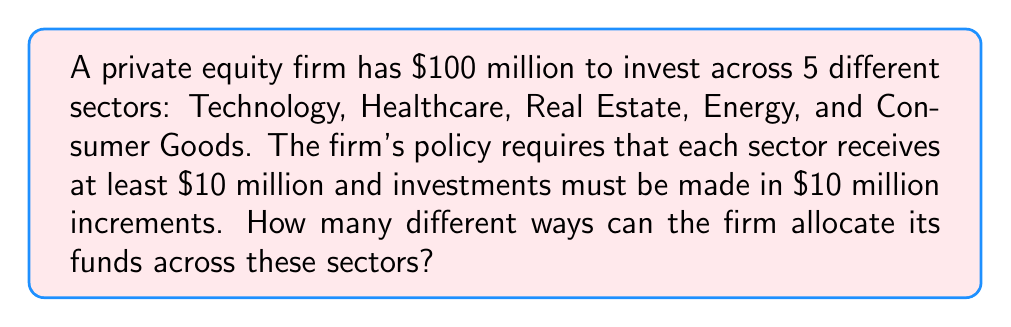Teach me how to tackle this problem. Let's approach this step-by-step:

1) First, we need to realize that this is a stars and bars problem with some constraints.

2) We have $100 million to distribute, but each sector must receive at least $10 million. So, we first allocate $10 million to each sector:

   $100 million - (5 * $10 million) = $50 million

3) Now, we need to distribute the remaining $50 million across 5 sectors in $10 million increments.

4) This is equivalent to distributing 5 indistinguishable balls (each representing $10 million) into 5 distinguishable boxes (the sectors).

5) The formula for this is:

   $$\binom{n+k-1}{k-1}$$

   Where $n$ is the number of indistinguishable objects (5 in our case) and $k$ is the number of distinguishable boxes (also 5 in our case).

6) Plugging in our values:

   $$\binom{5+5-1}{5-1} = \binom{9}{4}$$

7) We can calculate this as:

   $$\binom{9}{4} = \frac{9!}{4!(9-4)!} = \frac{9!}{4!5!} = 126$$

Therefore, there are 126 different ways to allocate the funds.
Answer: 126 ways 